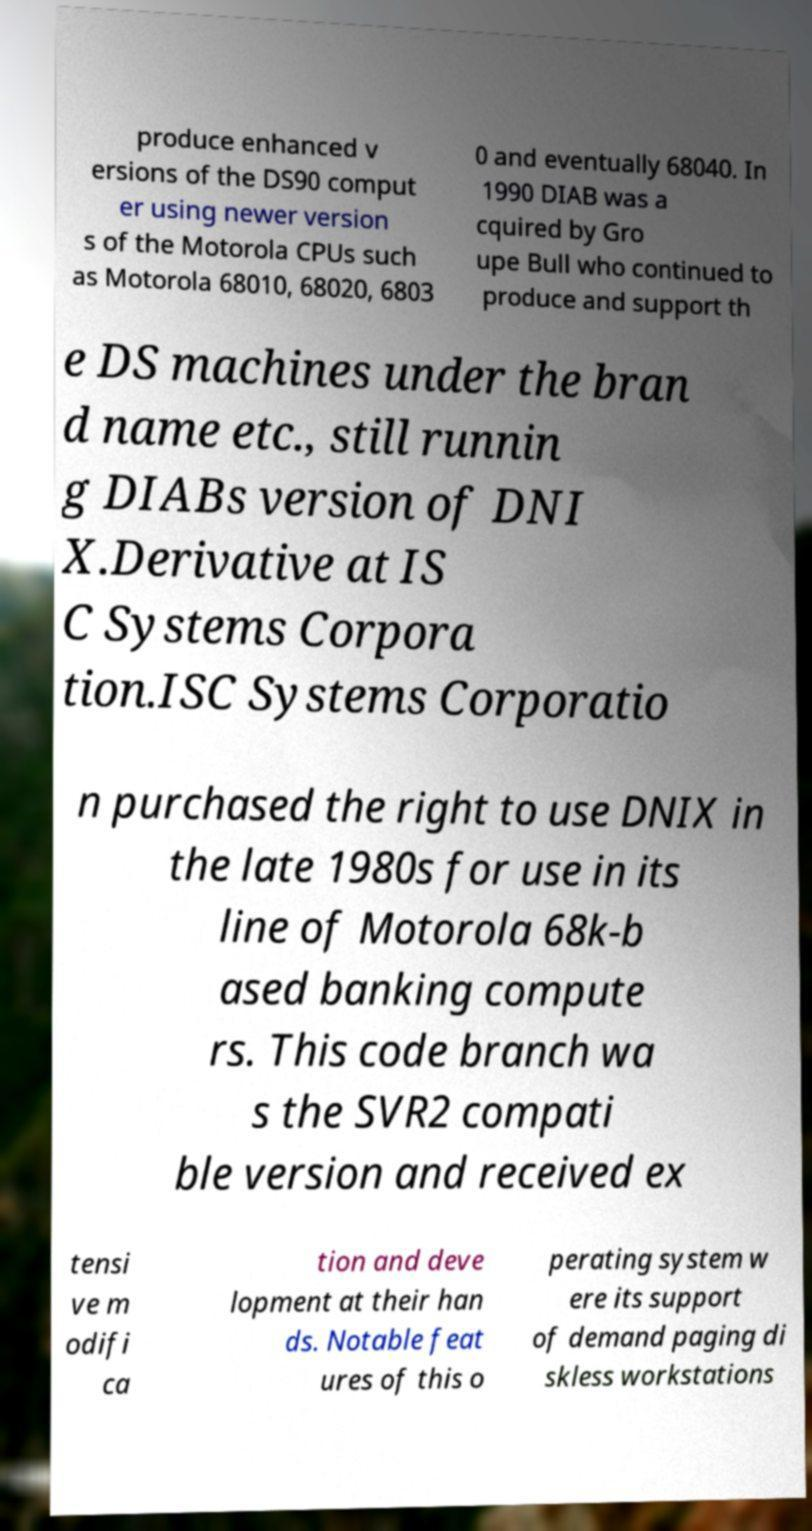What messages or text are displayed in this image? I need them in a readable, typed format. produce enhanced v ersions of the DS90 comput er using newer version s of the Motorola CPUs such as Motorola 68010, 68020, 6803 0 and eventually 68040. In 1990 DIAB was a cquired by Gro upe Bull who continued to produce and support th e DS machines under the bran d name etc., still runnin g DIABs version of DNI X.Derivative at IS C Systems Corpora tion.ISC Systems Corporatio n purchased the right to use DNIX in the late 1980s for use in its line of Motorola 68k-b ased banking compute rs. This code branch wa s the SVR2 compati ble version and received ex tensi ve m odifi ca tion and deve lopment at their han ds. Notable feat ures of this o perating system w ere its support of demand paging di skless workstations 